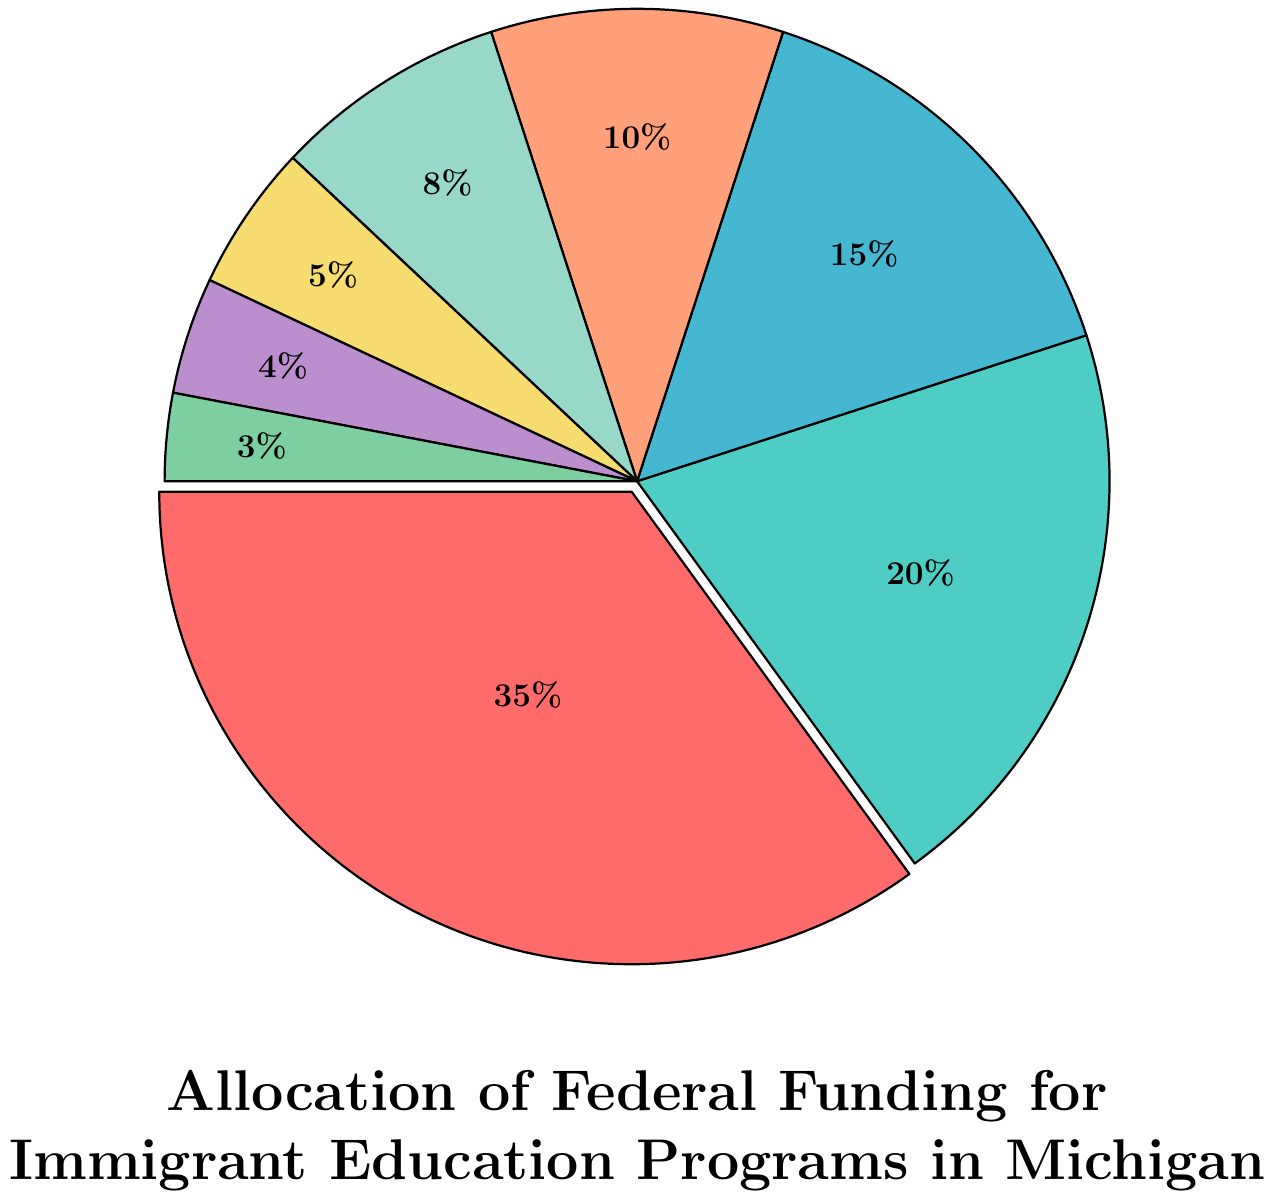What percentage of the funding is allocated to the two programs with the smallest allocations? The two programs with the smallest allocations are Bilingual Education Initiatives (3%) and Newcomer Programs (4%). Summing these percentages, 3% + 4% = 7%.
Answer: 7% Which program receives the most funding? By examining the pie chart, we can see that the largest segment represents English Language Acquisition with 35% of the funding.
Answer: English Language Acquisition How much more funding does Migrant Education receive compared to Refugee School Impact? Migrant Education receives 20% of the funding, while Refugee School Impact receives 10%. The difference is 20% - 10% = 10%.
Answer: 10% What is the fractional representation of the funding for Adult Education for Immigrants? Adult Education for Immigrants receives 15% of the total funding. As a fraction of 100, this is 15/100, which simplifies to 3/20.
Answer: 3/20 If Immigrant Integration and Citizenship funding was increased by 5 percentage points, what would its new allocation be? Initially, Immigrant Integration and Citizenship is allocated 8%. Increasing it by 5 percentage points, 8% + 5% = 13%.
Answer: 13% What percentage of the funding is allocated to both Newcomer Programs and Unaccompanied Minors Education combined? Newcomer Programs receive 4% and Unaccompanied Minors Education receives 5%. Summing these allocations, 4% + 5% = 9%.
Answer: 9% Which program is allocated 10% of the funding, and what is its color on the chart? Refugee School Impact is allocated 10% of the funding. According to the pie chart, it is represented by an orange color.
Answer: Refugee School Impact, orange What is the total percentage of funding allocated to programs with more than 10% funding each? English Language Acquisition (35%) and Migrant Education (20%) are the programs with more than 10% funding each. Summing these allocations, 35% + 20% = 55%.
Answer: 55% Which two programs have the closest funding allocations, and what are their percentages? Newcomer Programs (4%) and Bilingual Education Initiatives (3%) have the closest funding allocations. The difference between them is 1%.
Answer: Newcomer Programs (4%) and Bilingual Education Initiatives (3%), 4% and 3% What is the combined percentage for English Language Acquisition, Adult Education for Immigrants, and Immigrant Integration and Citizenship? The allocations are English Language Acquisition (35%), Adult Education for Immigrants (15%), and Immigrant Integration and Citizenship (8%). Adding them, 35% + 15% + 8% = 58%.
Answer: 58% 